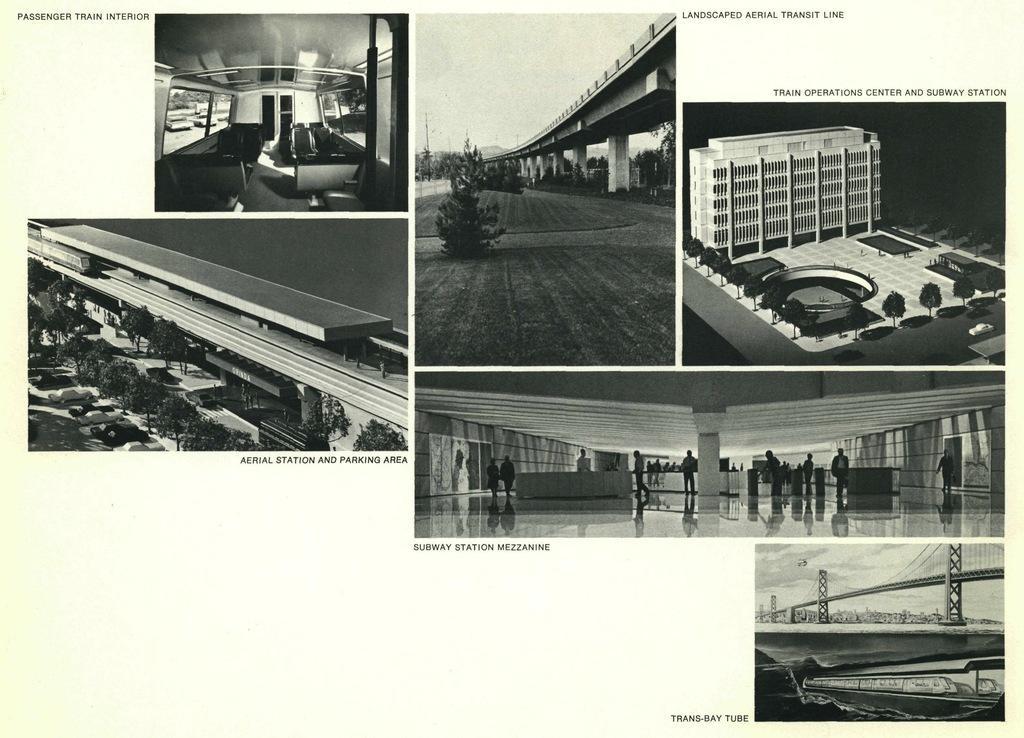Describe this image in one or two sentences. In this image I can see a collage photo. This image consists of a bridge, trees, vehicles, boat, the sky and a group of people. 